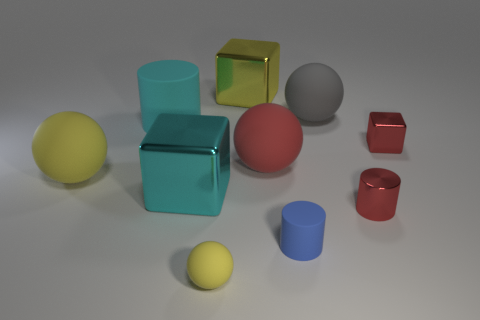Subtract all balls. How many objects are left? 6 Add 4 big rubber objects. How many big rubber objects exist? 8 Subtract 0 purple cylinders. How many objects are left? 10 Subtract all tiny red things. Subtract all cyan things. How many objects are left? 6 Add 5 big yellow balls. How many big yellow balls are left? 6 